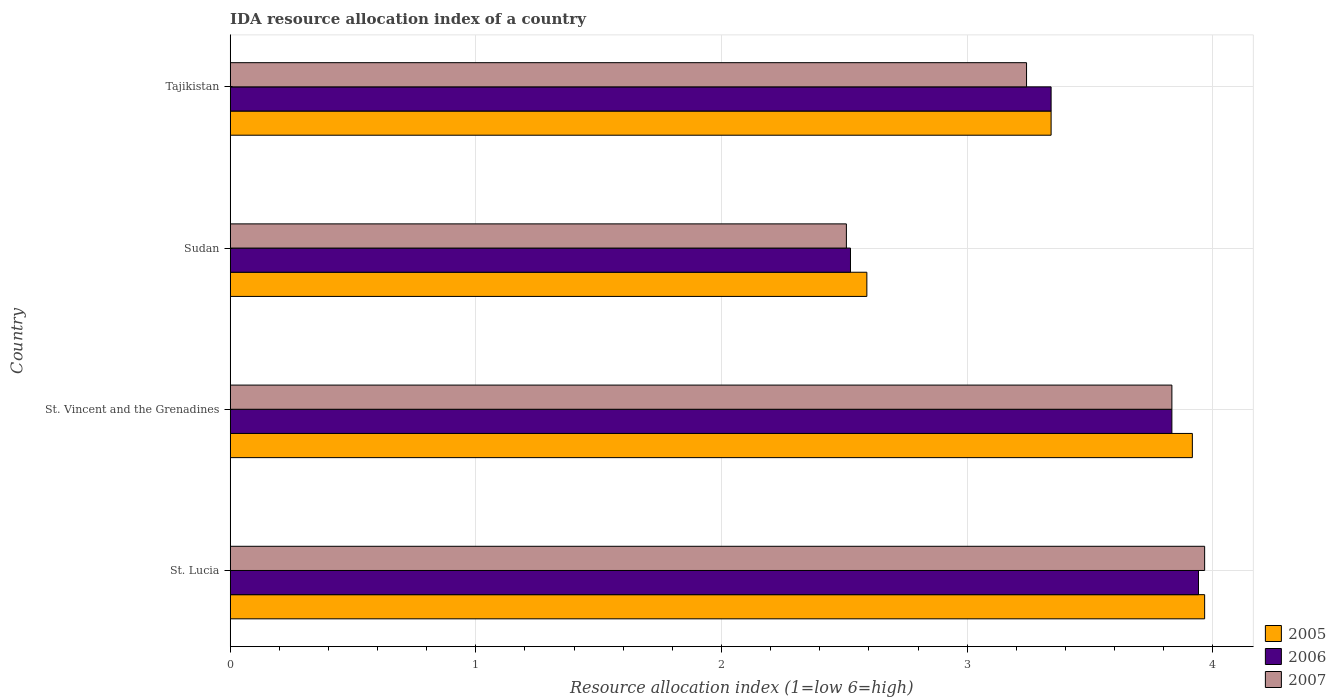How many groups of bars are there?
Make the answer very short. 4. How many bars are there on the 3rd tick from the bottom?
Provide a succinct answer. 3. What is the label of the 2nd group of bars from the top?
Provide a succinct answer. Sudan. In how many cases, is the number of bars for a given country not equal to the number of legend labels?
Keep it short and to the point. 0. What is the IDA resource allocation index in 2005 in Sudan?
Offer a very short reply. 2.59. Across all countries, what is the maximum IDA resource allocation index in 2006?
Your response must be concise. 3.94. Across all countries, what is the minimum IDA resource allocation index in 2005?
Your answer should be compact. 2.59. In which country was the IDA resource allocation index in 2005 maximum?
Provide a succinct answer. St. Lucia. In which country was the IDA resource allocation index in 2006 minimum?
Give a very brief answer. Sudan. What is the total IDA resource allocation index in 2005 in the graph?
Ensure brevity in your answer.  13.82. What is the difference between the IDA resource allocation index in 2007 in Sudan and that in Tajikistan?
Provide a succinct answer. -0.73. What is the difference between the IDA resource allocation index in 2005 in St. Vincent and the Grenadines and the IDA resource allocation index in 2006 in St. Lucia?
Offer a terse response. -0.02. What is the average IDA resource allocation index in 2006 per country?
Give a very brief answer. 3.41. What is the difference between the IDA resource allocation index in 2005 and IDA resource allocation index in 2006 in St. Vincent and the Grenadines?
Give a very brief answer. 0.08. In how many countries, is the IDA resource allocation index in 2007 greater than 3 ?
Your response must be concise. 3. What is the ratio of the IDA resource allocation index in 2006 in St. Vincent and the Grenadines to that in Tajikistan?
Offer a terse response. 1.15. Is the difference between the IDA resource allocation index in 2005 in St. Lucia and St. Vincent and the Grenadines greater than the difference between the IDA resource allocation index in 2006 in St. Lucia and St. Vincent and the Grenadines?
Give a very brief answer. No. What is the difference between the highest and the second highest IDA resource allocation index in 2006?
Ensure brevity in your answer.  0.11. What is the difference between the highest and the lowest IDA resource allocation index in 2005?
Ensure brevity in your answer.  1.38. In how many countries, is the IDA resource allocation index in 2006 greater than the average IDA resource allocation index in 2006 taken over all countries?
Provide a succinct answer. 2. Is the sum of the IDA resource allocation index in 2006 in St. Vincent and the Grenadines and Sudan greater than the maximum IDA resource allocation index in 2005 across all countries?
Keep it short and to the point. Yes. What does the 1st bar from the top in St. Lucia represents?
Your answer should be compact. 2007. What does the 2nd bar from the bottom in Sudan represents?
Ensure brevity in your answer.  2006. Is it the case that in every country, the sum of the IDA resource allocation index in 2006 and IDA resource allocation index in 2005 is greater than the IDA resource allocation index in 2007?
Your answer should be compact. Yes. Are all the bars in the graph horizontal?
Offer a terse response. Yes. How many countries are there in the graph?
Ensure brevity in your answer.  4. Are the values on the major ticks of X-axis written in scientific E-notation?
Ensure brevity in your answer.  No. Where does the legend appear in the graph?
Make the answer very short. Bottom right. How many legend labels are there?
Offer a terse response. 3. How are the legend labels stacked?
Your answer should be compact. Vertical. What is the title of the graph?
Keep it short and to the point. IDA resource allocation index of a country. Does "1975" appear as one of the legend labels in the graph?
Offer a very short reply. No. What is the label or title of the X-axis?
Ensure brevity in your answer.  Resource allocation index (1=low 6=high). What is the label or title of the Y-axis?
Ensure brevity in your answer.  Country. What is the Resource allocation index (1=low 6=high) of 2005 in St. Lucia?
Provide a short and direct response. 3.97. What is the Resource allocation index (1=low 6=high) of 2006 in St. Lucia?
Keep it short and to the point. 3.94. What is the Resource allocation index (1=low 6=high) of 2007 in St. Lucia?
Provide a succinct answer. 3.97. What is the Resource allocation index (1=low 6=high) in 2005 in St. Vincent and the Grenadines?
Your answer should be very brief. 3.92. What is the Resource allocation index (1=low 6=high) of 2006 in St. Vincent and the Grenadines?
Ensure brevity in your answer.  3.83. What is the Resource allocation index (1=low 6=high) of 2007 in St. Vincent and the Grenadines?
Offer a very short reply. 3.83. What is the Resource allocation index (1=low 6=high) of 2005 in Sudan?
Ensure brevity in your answer.  2.59. What is the Resource allocation index (1=low 6=high) in 2006 in Sudan?
Keep it short and to the point. 2.52. What is the Resource allocation index (1=low 6=high) in 2007 in Sudan?
Your answer should be very brief. 2.51. What is the Resource allocation index (1=low 6=high) of 2005 in Tajikistan?
Ensure brevity in your answer.  3.34. What is the Resource allocation index (1=low 6=high) of 2006 in Tajikistan?
Provide a succinct answer. 3.34. What is the Resource allocation index (1=low 6=high) of 2007 in Tajikistan?
Make the answer very short. 3.24. Across all countries, what is the maximum Resource allocation index (1=low 6=high) of 2005?
Provide a short and direct response. 3.97. Across all countries, what is the maximum Resource allocation index (1=low 6=high) of 2006?
Your answer should be very brief. 3.94. Across all countries, what is the maximum Resource allocation index (1=low 6=high) in 2007?
Give a very brief answer. 3.97. Across all countries, what is the minimum Resource allocation index (1=low 6=high) of 2005?
Offer a terse response. 2.59. Across all countries, what is the minimum Resource allocation index (1=low 6=high) of 2006?
Your answer should be very brief. 2.52. Across all countries, what is the minimum Resource allocation index (1=low 6=high) in 2007?
Keep it short and to the point. 2.51. What is the total Resource allocation index (1=low 6=high) of 2005 in the graph?
Provide a succinct answer. 13.82. What is the total Resource allocation index (1=low 6=high) of 2006 in the graph?
Your response must be concise. 13.64. What is the total Resource allocation index (1=low 6=high) in 2007 in the graph?
Make the answer very short. 13.55. What is the difference between the Resource allocation index (1=low 6=high) in 2006 in St. Lucia and that in St. Vincent and the Grenadines?
Offer a terse response. 0.11. What is the difference between the Resource allocation index (1=low 6=high) of 2007 in St. Lucia and that in St. Vincent and the Grenadines?
Your answer should be very brief. 0.13. What is the difference between the Resource allocation index (1=low 6=high) in 2005 in St. Lucia and that in Sudan?
Ensure brevity in your answer.  1.38. What is the difference between the Resource allocation index (1=low 6=high) of 2006 in St. Lucia and that in Sudan?
Give a very brief answer. 1.42. What is the difference between the Resource allocation index (1=low 6=high) of 2007 in St. Lucia and that in Sudan?
Your response must be concise. 1.46. What is the difference between the Resource allocation index (1=low 6=high) in 2006 in St. Lucia and that in Tajikistan?
Your answer should be very brief. 0.6. What is the difference between the Resource allocation index (1=low 6=high) in 2007 in St. Lucia and that in Tajikistan?
Your response must be concise. 0.72. What is the difference between the Resource allocation index (1=low 6=high) in 2005 in St. Vincent and the Grenadines and that in Sudan?
Your answer should be compact. 1.32. What is the difference between the Resource allocation index (1=low 6=high) of 2006 in St. Vincent and the Grenadines and that in Sudan?
Keep it short and to the point. 1.31. What is the difference between the Resource allocation index (1=low 6=high) of 2007 in St. Vincent and the Grenadines and that in Sudan?
Your answer should be very brief. 1.32. What is the difference between the Resource allocation index (1=low 6=high) of 2005 in St. Vincent and the Grenadines and that in Tajikistan?
Your response must be concise. 0.57. What is the difference between the Resource allocation index (1=low 6=high) in 2006 in St. Vincent and the Grenadines and that in Tajikistan?
Your answer should be very brief. 0.49. What is the difference between the Resource allocation index (1=low 6=high) in 2007 in St. Vincent and the Grenadines and that in Tajikistan?
Give a very brief answer. 0.59. What is the difference between the Resource allocation index (1=low 6=high) of 2005 in Sudan and that in Tajikistan?
Give a very brief answer. -0.75. What is the difference between the Resource allocation index (1=low 6=high) in 2006 in Sudan and that in Tajikistan?
Make the answer very short. -0.82. What is the difference between the Resource allocation index (1=low 6=high) in 2007 in Sudan and that in Tajikistan?
Your answer should be very brief. -0.73. What is the difference between the Resource allocation index (1=low 6=high) in 2005 in St. Lucia and the Resource allocation index (1=low 6=high) in 2006 in St. Vincent and the Grenadines?
Your response must be concise. 0.13. What is the difference between the Resource allocation index (1=low 6=high) in 2005 in St. Lucia and the Resource allocation index (1=low 6=high) in 2007 in St. Vincent and the Grenadines?
Your response must be concise. 0.13. What is the difference between the Resource allocation index (1=low 6=high) in 2006 in St. Lucia and the Resource allocation index (1=low 6=high) in 2007 in St. Vincent and the Grenadines?
Your response must be concise. 0.11. What is the difference between the Resource allocation index (1=low 6=high) in 2005 in St. Lucia and the Resource allocation index (1=low 6=high) in 2006 in Sudan?
Make the answer very short. 1.44. What is the difference between the Resource allocation index (1=low 6=high) of 2005 in St. Lucia and the Resource allocation index (1=low 6=high) of 2007 in Sudan?
Keep it short and to the point. 1.46. What is the difference between the Resource allocation index (1=low 6=high) in 2006 in St. Lucia and the Resource allocation index (1=low 6=high) in 2007 in Sudan?
Offer a very short reply. 1.43. What is the difference between the Resource allocation index (1=low 6=high) in 2005 in St. Lucia and the Resource allocation index (1=low 6=high) in 2006 in Tajikistan?
Your answer should be compact. 0.62. What is the difference between the Resource allocation index (1=low 6=high) in 2005 in St. Lucia and the Resource allocation index (1=low 6=high) in 2007 in Tajikistan?
Your response must be concise. 0.72. What is the difference between the Resource allocation index (1=low 6=high) of 2005 in St. Vincent and the Grenadines and the Resource allocation index (1=low 6=high) of 2006 in Sudan?
Ensure brevity in your answer.  1.39. What is the difference between the Resource allocation index (1=low 6=high) in 2005 in St. Vincent and the Grenadines and the Resource allocation index (1=low 6=high) in 2007 in Sudan?
Offer a very short reply. 1.41. What is the difference between the Resource allocation index (1=low 6=high) of 2006 in St. Vincent and the Grenadines and the Resource allocation index (1=low 6=high) of 2007 in Sudan?
Your answer should be compact. 1.32. What is the difference between the Resource allocation index (1=low 6=high) of 2005 in St. Vincent and the Grenadines and the Resource allocation index (1=low 6=high) of 2006 in Tajikistan?
Provide a short and direct response. 0.57. What is the difference between the Resource allocation index (1=low 6=high) in 2005 in St. Vincent and the Grenadines and the Resource allocation index (1=low 6=high) in 2007 in Tajikistan?
Offer a terse response. 0.68. What is the difference between the Resource allocation index (1=low 6=high) of 2006 in St. Vincent and the Grenadines and the Resource allocation index (1=low 6=high) of 2007 in Tajikistan?
Make the answer very short. 0.59. What is the difference between the Resource allocation index (1=low 6=high) in 2005 in Sudan and the Resource allocation index (1=low 6=high) in 2006 in Tajikistan?
Give a very brief answer. -0.75. What is the difference between the Resource allocation index (1=low 6=high) in 2005 in Sudan and the Resource allocation index (1=low 6=high) in 2007 in Tajikistan?
Your answer should be compact. -0.65. What is the difference between the Resource allocation index (1=low 6=high) in 2006 in Sudan and the Resource allocation index (1=low 6=high) in 2007 in Tajikistan?
Your answer should be very brief. -0.72. What is the average Resource allocation index (1=low 6=high) in 2005 per country?
Your response must be concise. 3.45. What is the average Resource allocation index (1=low 6=high) of 2006 per country?
Provide a succinct answer. 3.41. What is the average Resource allocation index (1=low 6=high) of 2007 per country?
Keep it short and to the point. 3.39. What is the difference between the Resource allocation index (1=low 6=high) in 2005 and Resource allocation index (1=low 6=high) in 2006 in St. Lucia?
Make the answer very short. 0.03. What is the difference between the Resource allocation index (1=low 6=high) in 2005 and Resource allocation index (1=low 6=high) in 2007 in St. Lucia?
Provide a succinct answer. 0. What is the difference between the Resource allocation index (1=low 6=high) of 2006 and Resource allocation index (1=low 6=high) of 2007 in St. Lucia?
Ensure brevity in your answer.  -0.03. What is the difference between the Resource allocation index (1=low 6=high) of 2005 and Resource allocation index (1=low 6=high) of 2006 in St. Vincent and the Grenadines?
Provide a succinct answer. 0.08. What is the difference between the Resource allocation index (1=low 6=high) in 2005 and Resource allocation index (1=low 6=high) in 2007 in St. Vincent and the Grenadines?
Your answer should be very brief. 0.08. What is the difference between the Resource allocation index (1=low 6=high) of 2005 and Resource allocation index (1=low 6=high) of 2006 in Sudan?
Your response must be concise. 0.07. What is the difference between the Resource allocation index (1=low 6=high) of 2005 and Resource allocation index (1=low 6=high) of 2007 in Sudan?
Give a very brief answer. 0.08. What is the difference between the Resource allocation index (1=low 6=high) in 2006 and Resource allocation index (1=low 6=high) in 2007 in Sudan?
Make the answer very short. 0.02. What is the difference between the Resource allocation index (1=low 6=high) in 2005 and Resource allocation index (1=low 6=high) in 2006 in Tajikistan?
Your response must be concise. 0. What is the difference between the Resource allocation index (1=low 6=high) in 2006 and Resource allocation index (1=low 6=high) in 2007 in Tajikistan?
Ensure brevity in your answer.  0.1. What is the ratio of the Resource allocation index (1=low 6=high) in 2005 in St. Lucia to that in St. Vincent and the Grenadines?
Offer a terse response. 1.01. What is the ratio of the Resource allocation index (1=low 6=high) in 2006 in St. Lucia to that in St. Vincent and the Grenadines?
Your answer should be very brief. 1.03. What is the ratio of the Resource allocation index (1=low 6=high) in 2007 in St. Lucia to that in St. Vincent and the Grenadines?
Keep it short and to the point. 1.03. What is the ratio of the Resource allocation index (1=low 6=high) of 2005 in St. Lucia to that in Sudan?
Offer a terse response. 1.53. What is the ratio of the Resource allocation index (1=low 6=high) of 2006 in St. Lucia to that in Sudan?
Provide a short and direct response. 1.56. What is the ratio of the Resource allocation index (1=low 6=high) in 2007 in St. Lucia to that in Sudan?
Your answer should be compact. 1.58. What is the ratio of the Resource allocation index (1=low 6=high) of 2005 in St. Lucia to that in Tajikistan?
Keep it short and to the point. 1.19. What is the ratio of the Resource allocation index (1=low 6=high) of 2006 in St. Lucia to that in Tajikistan?
Provide a short and direct response. 1.18. What is the ratio of the Resource allocation index (1=low 6=high) of 2007 in St. Lucia to that in Tajikistan?
Provide a succinct answer. 1.22. What is the ratio of the Resource allocation index (1=low 6=high) in 2005 in St. Vincent and the Grenadines to that in Sudan?
Offer a very short reply. 1.51. What is the ratio of the Resource allocation index (1=low 6=high) of 2006 in St. Vincent and the Grenadines to that in Sudan?
Your answer should be very brief. 1.52. What is the ratio of the Resource allocation index (1=low 6=high) in 2007 in St. Vincent and the Grenadines to that in Sudan?
Your answer should be very brief. 1.53. What is the ratio of the Resource allocation index (1=low 6=high) in 2005 in St. Vincent and the Grenadines to that in Tajikistan?
Your response must be concise. 1.17. What is the ratio of the Resource allocation index (1=low 6=high) in 2006 in St. Vincent and the Grenadines to that in Tajikistan?
Ensure brevity in your answer.  1.15. What is the ratio of the Resource allocation index (1=low 6=high) in 2007 in St. Vincent and the Grenadines to that in Tajikistan?
Offer a terse response. 1.18. What is the ratio of the Resource allocation index (1=low 6=high) in 2005 in Sudan to that in Tajikistan?
Your answer should be very brief. 0.78. What is the ratio of the Resource allocation index (1=low 6=high) in 2006 in Sudan to that in Tajikistan?
Your answer should be compact. 0.76. What is the ratio of the Resource allocation index (1=low 6=high) in 2007 in Sudan to that in Tajikistan?
Ensure brevity in your answer.  0.77. What is the difference between the highest and the second highest Resource allocation index (1=low 6=high) of 2005?
Offer a very short reply. 0.05. What is the difference between the highest and the second highest Resource allocation index (1=low 6=high) in 2006?
Offer a terse response. 0.11. What is the difference between the highest and the second highest Resource allocation index (1=low 6=high) of 2007?
Your response must be concise. 0.13. What is the difference between the highest and the lowest Resource allocation index (1=low 6=high) in 2005?
Offer a terse response. 1.38. What is the difference between the highest and the lowest Resource allocation index (1=low 6=high) in 2006?
Your answer should be very brief. 1.42. What is the difference between the highest and the lowest Resource allocation index (1=low 6=high) in 2007?
Provide a short and direct response. 1.46. 